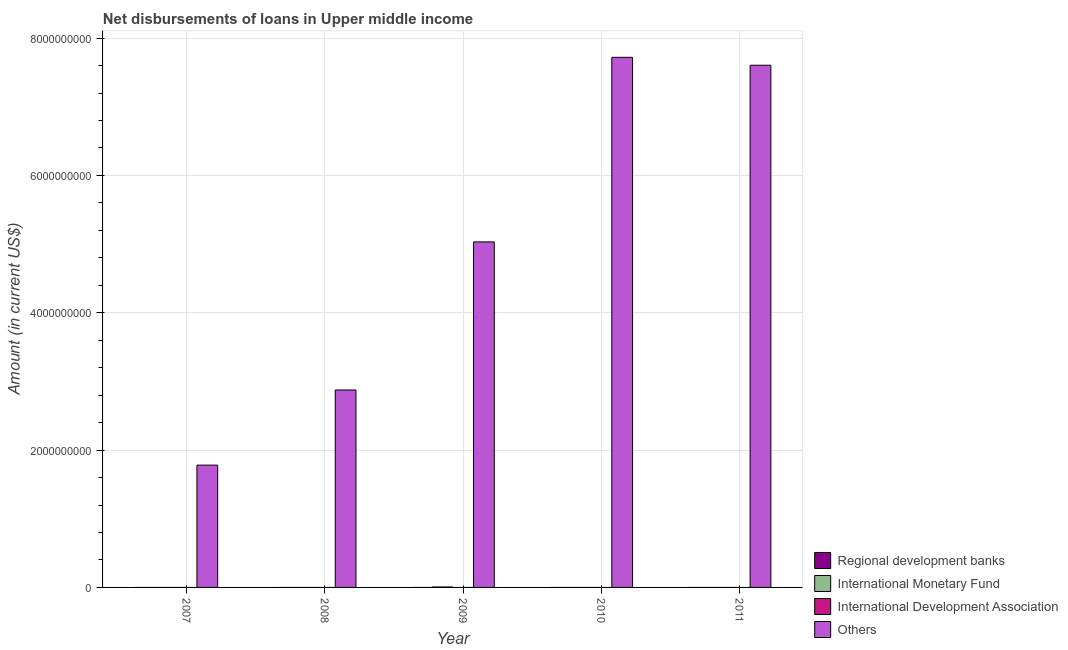How many different coloured bars are there?
Give a very brief answer. 2. How many bars are there on the 5th tick from the right?
Your response must be concise. 1. What is the label of the 3rd group of bars from the left?
Your answer should be very brief. 2009. In how many cases, is the number of bars for a given year not equal to the number of legend labels?
Make the answer very short. 5. What is the amount of loan disimbursed by international development association in 2010?
Give a very brief answer. 0. Across all years, what is the maximum amount of loan disimbursed by international monetary fund?
Your answer should be very brief. 6.46e+06. In which year was the amount of loan disimbursed by international monetary fund maximum?
Offer a very short reply. 2009. What is the total amount of loan disimbursed by other organisations in the graph?
Provide a succinct answer. 2.50e+1. What is the difference between the amount of loan disimbursed by other organisations in 2008 and that in 2011?
Your answer should be compact. -4.73e+09. What is the difference between the amount of loan disimbursed by international monetary fund in 2011 and the amount of loan disimbursed by international development association in 2007?
Your answer should be compact. 0. What is the average amount of loan disimbursed by international development association per year?
Your response must be concise. 0. In the year 2009, what is the difference between the amount of loan disimbursed by international monetary fund and amount of loan disimbursed by international development association?
Provide a succinct answer. 0. What is the difference between the highest and the second highest amount of loan disimbursed by other organisations?
Provide a succinct answer. 1.15e+08. What is the difference between the highest and the lowest amount of loan disimbursed by international monetary fund?
Keep it short and to the point. 6.46e+06. In how many years, is the amount of loan disimbursed by international monetary fund greater than the average amount of loan disimbursed by international monetary fund taken over all years?
Make the answer very short. 1. Is it the case that in every year, the sum of the amount of loan disimbursed by regional development banks and amount of loan disimbursed by international monetary fund is greater than the amount of loan disimbursed by international development association?
Your answer should be compact. No. How many years are there in the graph?
Give a very brief answer. 5. Does the graph contain any zero values?
Offer a very short reply. Yes. Does the graph contain grids?
Give a very brief answer. Yes. How many legend labels are there?
Give a very brief answer. 4. How are the legend labels stacked?
Provide a succinct answer. Vertical. What is the title of the graph?
Offer a very short reply. Net disbursements of loans in Upper middle income. What is the label or title of the X-axis?
Offer a terse response. Year. What is the label or title of the Y-axis?
Give a very brief answer. Amount (in current US$). What is the Amount (in current US$) in Regional development banks in 2007?
Offer a very short reply. 0. What is the Amount (in current US$) in International Development Association in 2007?
Keep it short and to the point. 0. What is the Amount (in current US$) in Others in 2007?
Provide a succinct answer. 1.78e+09. What is the Amount (in current US$) of International Monetary Fund in 2008?
Offer a terse response. 0. What is the Amount (in current US$) in International Development Association in 2008?
Offer a very short reply. 0. What is the Amount (in current US$) in Others in 2008?
Ensure brevity in your answer.  2.88e+09. What is the Amount (in current US$) of International Monetary Fund in 2009?
Ensure brevity in your answer.  6.46e+06. What is the Amount (in current US$) of International Development Association in 2009?
Your answer should be very brief. 0. What is the Amount (in current US$) of Others in 2009?
Your answer should be very brief. 5.03e+09. What is the Amount (in current US$) in International Development Association in 2010?
Ensure brevity in your answer.  0. What is the Amount (in current US$) in Others in 2010?
Make the answer very short. 7.72e+09. What is the Amount (in current US$) of International Development Association in 2011?
Ensure brevity in your answer.  0. What is the Amount (in current US$) of Others in 2011?
Keep it short and to the point. 7.61e+09. Across all years, what is the maximum Amount (in current US$) in International Monetary Fund?
Keep it short and to the point. 6.46e+06. Across all years, what is the maximum Amount (in current US$) of Others?
Your answer should be very brief. 7.72e+09. Across all years, what is the minimum Amount (in current US$) of Others?
Give a very brief answer. 1.78e+09. What is the total Amount (in current US$) in Regional development banks in the graph?
Offer a terse response. 0. What is the total Amount (in current US$) of International Monetary Fund in the graph?
Provide a short and direct response. 6.46e+06. What is the total Amount (in current US$) in International Development Association in the graph?
Offer a very short reply. 0. What is the total Amount (in current US$) in Others in the graph?
Offer a very short reply. 2.50e+1. What is the difference between the Amount (in current US$) in Others in 2007 and that in 2008?
Provide a short and direct response. -1.09e+09. What is the difference between the Amount (in current US$) in Others in 2007 and that in 2009?
Offer a terse response. -3.25e+09. What is the difference between the Amount (in current US$) of Others in 2007 and that in 2010?
Your answer should be compact. -5.94e+09. What is the difference between the Amount (in current US$) of Others in 2007 and that in 2011?
Your answer should be compact. -5.82e+09. What is the difference between the Amount (in current US$) in Others in 2008 and that in 2009?
Offer a terse response. -2.16e+09. What is the difference between the Amount (in current US$) of Others in 2008 and that in 2010?
Give a very brief answer. -4.84e+09. What is the difference between the Amount (in current US$) in Others in 2008 and that in 2011?
Ensure brevity in your answer.  -4.73e+09. What is the difference between the Amount (in current US$) in Others in 2009 and that in 2010?
Keep it short and to the point. -2.69e+09. What is the difference between the Amount (in current US$) in Others in 2009 and that in 2011?
Ensure brevity in your answer.  -2.57e+09. What is the difference between the Amount (in current US$) in Others in 2010 and that in 2011?
Your answer should be compact. 1.15e+08. What is the difference between the Amount (in current US$) in International Monetary Fund in 2009 and the Amount (in current US$) in Others in 2010?
Offer a very short reply. -7.71e+09. What is the difference between the Amount (in current US$) in International Monetary Fund in 2009 and the Amount (in current US$) in Others in 2011?
Make the answer very short. -7.60e+09. What is the average Amount (in current US$) in International Monetary Fund per year?
Provide a short and direct response. 1.29e+06. What is the average Amount (in current US$) in Others per year?
Make the answer very short. 5.00e+09. In the year 2009, what is the difference between the Amount (in current US$) of International Monetary Fund and Amount (in current US$) of Others?
Provide a short and direct response. -5.03e+09. What is the ratio of the Amount (in current US$) in Others in 2007 to that in 2008?
Ensure brevity in your answer.  0.62. What is the ratio of the Amount (in current US$) in Others in 2007 to that in 2009?
Provide a short and direct response. 0.35. What is the ratio of the Amount (in current US$) in Others in 2007 to that in 2010?
Your answer should be very brief. 0.23. What is the ratio of the Amount (in current US$) in Others in 2007 to that in 2011?
Keep it short and to the point. 0.23. What is the ratio of the Amount (in current US$) in Others in 2008 to that in 2010?
Make the answer very short. 0.37. What is the ratio of the Amount (in current US$) in Others in 2008 to that in 2011?
Make the answer very short. 0.38. What is the ratio of the Amount (in current US$) of Others in 2009 to that in 2010?
Your response must be concise. 0.65. What is the ratio of the Amount (in current US$) of Others in 2009 to that in 2011?
Your answer should be very brief. 0.66. What is the ratio of the Amount (in current US$) in Others in 2010 to that in 2011?
Make the answer very short. 1.02. What is the difference between the highest and the second highest Amount (in current US$) of Others?
Provide a succinct answer. 1.15e+08. What is the difference between the highest and the lowest Amount (in current US$) of International Monetary Fund?
Your answer should be compact. 6.46e+06. What is the difference between the highest and the lowest Amount (in current US$) in Others?
Your answer should be compact. 5.94e+09. 